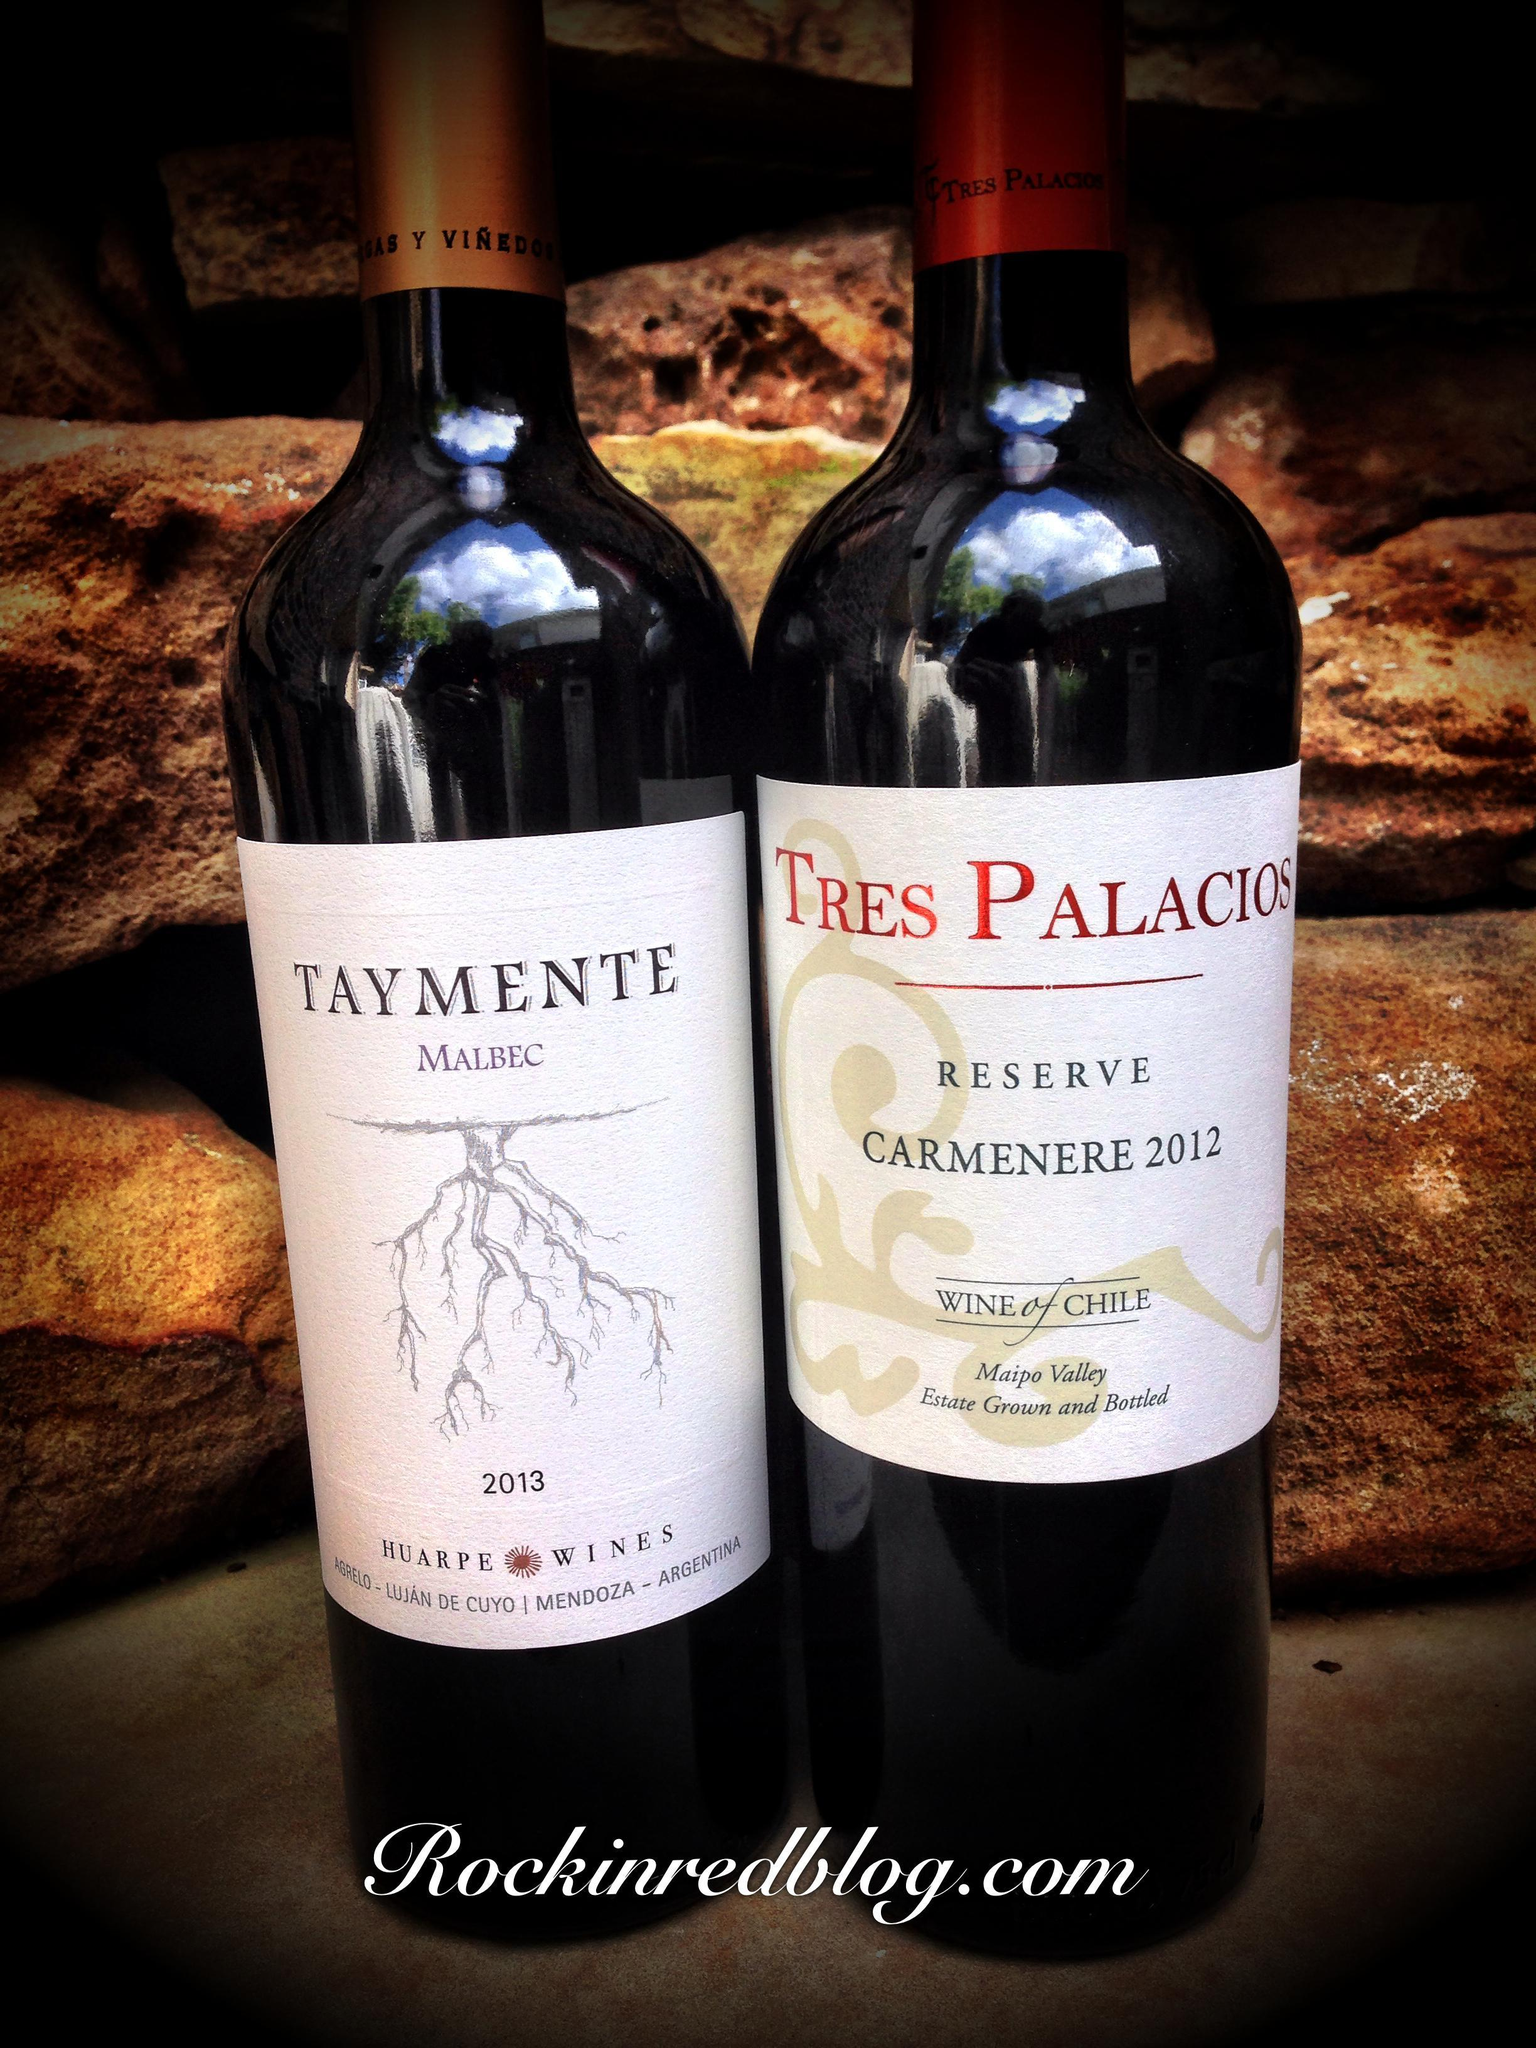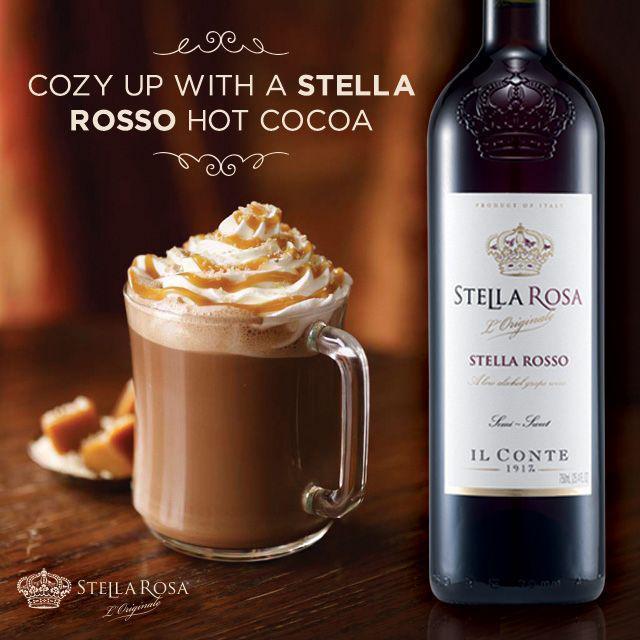The first image is the image on the left, the second image is the image on the right. Evaluate the accuracy of this statement regarding the images: "In one of the images there are two wine bottles next to each other.". Is it true? Answer yes or no. Yes. 